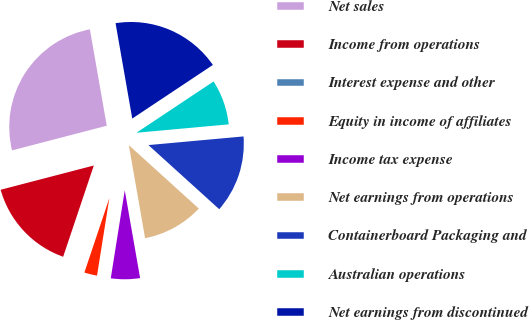Convert chart. <chart><loc_0><loc_0><loc_500><loc_500><pie_chart><fcel>Net sales<fcel>Income from operations<fcel>Interest expense and other<fcel>Equity in income of affiliates<fcel>Income tax expense<fcel>Net earnings from operations<fcel>Containerboard Packaging and<fcel>Australian operations<fcel>Net earnings from discontinued<nl><fcel>26.3%<fcel>15.79%<fcel>0.01%<fcel>2.64%<fcel>5.27%<fcel>10.53%<fcel>13.16%<fcel>7.9%<fcel>18.42%<nl></chart> 